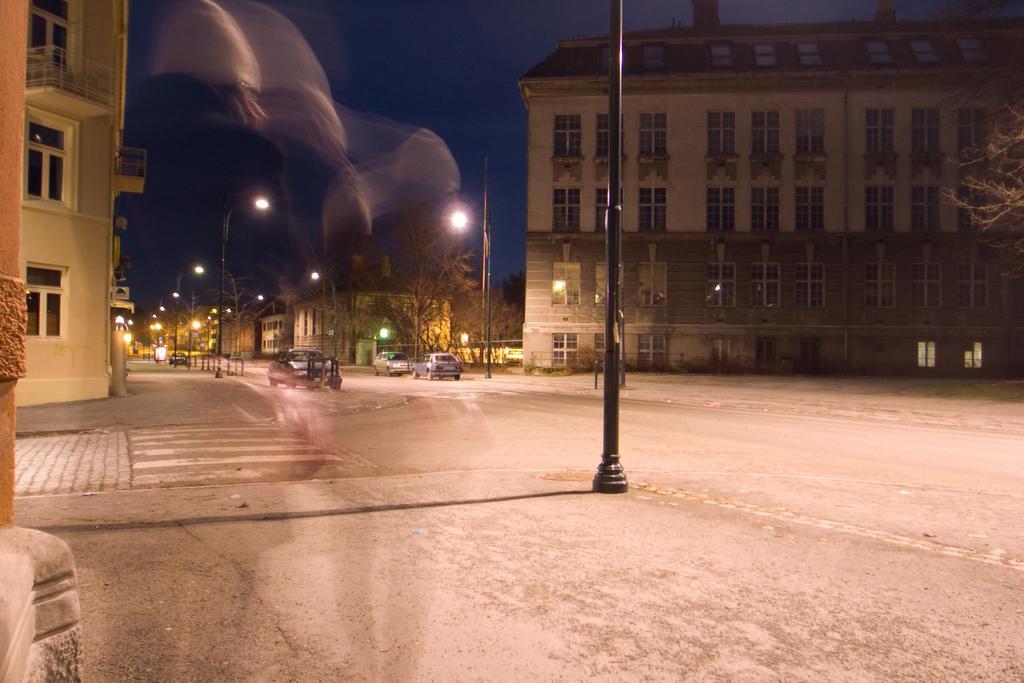In one or two sentences, can you explain what this image depicts? In this image in the foreground there are some buildings poles and street lights, and on the road there are some vehicles. On the right side and left side there are some buildings, on the top of the image there is sky. 